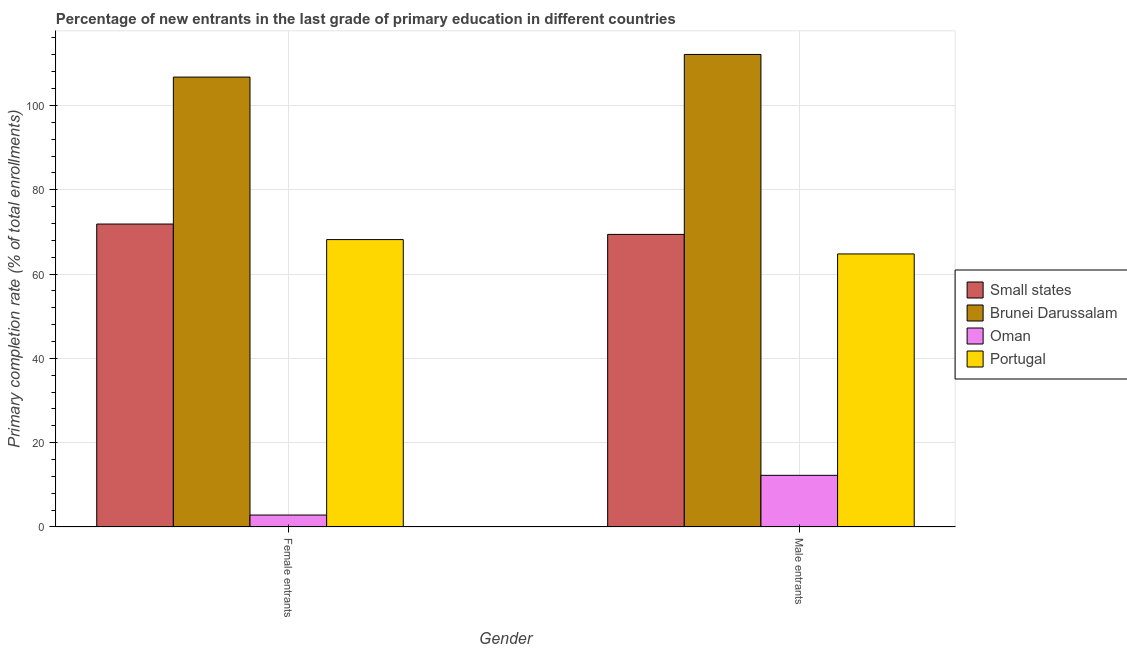How many different coloured bars are there?
Your response must be concise. 4. How many groups of bars are there?
Your answer should be very brief. 2. Are the number of bars per tick equal to the number of legend labels?
Your answer should be compact. Yes. Are the number of bars on each tick of the X-axis equal?
Give a very brief answer. Yes. What is the label of the 2nd group of bars from the left?
Provide a succinct answer. Male entrants. What is the primary completion rate of male entrants in Oman?
Ensure brevity in your answer.  12.26. Across all countries, what is the maximum primary completion rate of female entrants?
Give a very brief answer. 106.72. Across all countries, what is the minimum primary completion rate of male entrants?
Provide a short and direct response. 12.26. In which country was the primary completion rate of female entrants maximum?
Make the answer very short. Brunei Darussalam. In which country was the primary completion rate of male entrants minimum?
Your response must be concise. Oman. What is the total primary completion rate of female entrants in the graph?
Keep it short and to the point. 249.6. What is the difference between the primary completion rate of female entrants in Brunei Darussalam and that in Oman?
Provide a succinct answer. 103.89. What is the difference between the primary completion rate of male entrants in Small states and the primary completion rate of female entrants in Portugal?
Make the answer very short. 1.23. What is the average primary completion rate of female entrants per country?
Your response must be concise. 62.4. What is the difference between the primary completion rate of male entrants and primary completion rate of female entrants in Portugal?
Provide a short and direct response. -3.4. What is the ratio of the primary completion rate of female entrants in Oman to that in Brunei Darussalam?
Provide a succinct answer. 0.03. Is the primary completion rate of male entrants in Oman less than that in Brunei Darussalam?
Your answer should be very brief. Yes. In how many countries, is the primary completion rate of female entrants greater than the average primary completion rate of female entrants taken over all countries?
Provide a succinct answer. 3. What does the 4th bar from the left in Male entrants represents?
Offer a terse response. Portugal. What does the 4th bar from the right in Male entrants represents?
Provide a short and direct response. Small states. Does the graph contain any zero values?
Provide a succinct answer. No. Does the graph contain grids?
Your response must be concise. Yes. What is the title of the graph?
Make the answer very short. Percentage of new entrants in the last grade of primary education in different countries. Does "Belarus" appear as one of the legend labels in the graph?
Offer a very short reply. No. What is the label or title of the Y-axis?
Ensure brevity in your answer.  Primary completion rate (% of total enrollments). What is the Primary completion rate (% of total enrollments) of Small states in Female entrants?
Make the answer very short. 71.86. What is the Primary completion rate (% of total enrollments) in Brunei Darussalam in Female entrants?
Offer a terse response. 106.72. What is the Primary completion rate (% of total enrollments) in Oman in Female entrants?
Your response must be concise. 2.83. What is the Primary completion rate (% of total enrollments) in Portugal in Female entrants?
Give a very brief answer. 68.18. What is the Primary completion rate (% of total enrollments) in Small states in Male entrants?
Your answer should be compact. 69.41. What is the Primary completion rate (% of total enrollments) in Brunei Darussalam in Male entrants?
Ensure brevity in your answer.  112.09. What is the Primary completion rate (% of total enrollments) of Oman in Male entrants?
Offer a very short reply. 12.26. What is the Primary completion rate (% of total enrollments) in Portugal in Male entrants?
Keep it short and to the point. 64.77. Across all Gender, what is the maximum Primary completion rate (% of total enrollments) in Small states?
Your answer should be compact. 71.86. Across all Gender, what is the maximum Primary completion rate (% of total enrollments) in Brunei Darussalam?
Provide a short and direct response. 112.09. Across all Gender, what is the maximum Primary completion rate (% of total enrollments) in Oman?
Offer a very short reply. 12.26. Across all Gender, what is the maximum Primary completion rate (% of total enrollments) in Portugal?
Your answer should be very brief. 68.18. Across all Gender, what is the minimum Primary completion rate (% of total enrollments) of Small states?
Offer a very short reply. 69.41. Across all Gender, what is the minimum Primary completion rate (% of total enrollments) in Brunei Darussalam?
Offer a very short reply. 106.72. Across all Gender, what is the minimum Primary completion rate (% of total enrollments) in Oman?
Ensure brevity in your answer.  2.83. Across all Gender, what is the minimum Primary completion rate (% of total enrollments) of Portugal?
Provide a succinct answer. 64.77. What is the total Primary completion rate (% of total enrollments) in Small states in the graph?
Provide a short and direct response. 141.27. What is the total Primary completion rate (% of total enrollments) in Brunei Darussalam in the graph?
Your answer should be compact. 218.81. What is the total Primary completion rate (% of total enrollments) of Oman in the graph?
Make the answer very short. 15.09. What is the total Primary completion rate (% of total enrollments) of Portugal in the graph?
Ensure brevity in your answer.  132.95. What is the difference between the Primary completion rate (% of total enrollments) of Small states in Female entrants and that in Male entrants?
Your response must be concise. 2.46. What is the difference between the Primary completion rate (% of total enrollments) of Brunei Darussalam in Female entrants and that in Male entrants?
Provide a succinct answer. -5.37. What is the difference between the Primary completion rate (% of total enrollments) of Oman in Female entrants and that in Male entrants?
Your answer should be very brief. -9.42. What is the difference between the Primary completion rate (% of total enrollments) in Portugal in Female entrants and that in Male entrants?
Offer a terse response. 3.4. What is the difference between the Primary completion rate (% of total enrollments) in Small states in Female entrants and the Primary completion rate (% of total enrollments) in Brunei Darussalam in Male entrants?
Give a very brief answer. -40.23. What is the difference between the Primary completion rate (% of total enrollments) of Small states in Female entrants and the Primary completion rate (% of total enrollments) of Oman in Male entrants?
Provide a succinct answer. 59.61. What is the difference between the Primary completion rate (% of total enrollments) in Small states in Female entrants and the Primary completion rate (% of total enrollments) in Portugal in Male entrants?
Your answer should be very brief. 7.09. What is the difference between the Primary completion rate (% of total enrollments) in Brunei Darussalam in Female entrants and the Primary completion rate (% of total enrollments) in Oman in Male entrants?
Your response must be concise. 94.47. What is the difference between the Primary completion rate (% of total enrollments) of Brunei Darussalam in Female entrants and the Primary completion rate (% of total enrollments) of Portugal in Male entrants?
Your answer should be very brief. 41.95. What is the difference between the Primary completion rate (% of total enrollments) of Oman in Female entrants and the Primary completion rate (% of total enrollments) of Portugal in Male entrants?
Ensure brevity in your answer.  -61.94. What is the average Primary completion rate (% of total enrollments) in Small states per Gender?
Your answer should be very brief. 70.64. What is the average Primary completion rate (% of total enrollments) of Brunei Darussalam per Gender?
Offer a very short reply. 109.41. What is the average Primary completion rate (% of total enrollments) in Oman per Gender?
Offer a terse response. 7.55. What is the average Primary completion rate (% of total enrollments) of Portugal per Gender?
Offer a very short reply. 66.47. What is the difference between the Primary completion rate (% of total enrollments) of Small states and Primary completion rate (% of total enrollments) of Brunei Darussalam in Female entrants?
Keep it short and to the point. -34.86. What is the difference between the Primary completion rate (% of total enrollments) in Small states and Primary completion rate (% of total enrollments) in Oman in Female entrants?
Provide a short and direct response. 69.03. What is the difference between the Primary completion rate (% of total enrollments) of Small states and Primary completion rate (% of total enrollments) of Portugal in Female entrants?
Make the answer very short. 3.69. What is the difference between the Primary completion rate (% of total enrollments) of Brunei Darussalam and Primary completion rate (% of total enrollments) of Oman in Female entrants?
Keep it short and to the point. 103.89. What is the difference between the Primary completion rate (% of total enrollments) of Brunei Darussalam and Primary completion rate (% of total enrollments) of Portugal in Female entrants?
Offer a terse response. 38.55. What is the difference between the Primary completion rate (% of total enrollments) in Oman and Primary completion rate (% of total enrollments) in Portugal in Female entrants?
Your response must be concise. -65.34. What is the difference between the Primary completion rate (% of total enrollments) of Small states and Primary completion rate (% of total enrollments) of Brunei Darussalam in Male entrants?
Offer a terse response. -42.68. What is the difference between the Primary completion rate (% of total enrollments) in Small states and Primary completion rate (% of total enrollments) in Oman in Male entrants?
Ensure brevity in your answer.  57.15. What is the difference between the Primary completion rate (% of total enrollments) in Small states and Primary completion rate (% of total enrollments) in Portugal in Male entrants?
Make the answer very short. 4.64. What is the difference between the Primary completion rate (% of total enrollments) in Brunei Darussalam and Primary completion rate (% of total enrollments) in Oman in Male entrants?
Your answer should be very brief. 99.84. What is the difference between the Primary completion rate (% of total enrollments) of Brunei Darussalam and Primary completion rate (% of total enrollments) of Portugal in Male entrants?
Keep it short and to the point. 47.32. What is the difference between the Primary completion rate (% of total enrollments) of Oman and Primary completion rate (% of total enrollments) of Portugal in Male entrants?
Provide a succinct answer. -52.51. What is the ratio of the Primary completion rate (% of total enrollments) in Small states in Female entrants to that in Male entrants?
Provide a short and direct response. 1.04. What is the ratio of the Primary completion rate (% of total enrollments) in Brunei Darussalam in Female entrants to that in Male entrants?
Make the answer very short. 0.95. What is the ratio of the Primary completion rate (% of total enrollments) of Oman in Female entrants to that in Male entrants?
Offer a terse response. 0.23. What is the ratio of the Primary completion rate (% of total enrollments) in Portugal in Female entrants to that in Male entrants?
Your response must be concise. 1.05. What is the difference between the highest and the second highest Primary completion rate (% of total enrollments) in Small states?
Keep it short and to the point. 2.46. What is the difference between the highest and the second highest Primary completion rate (% of total enrollments) of Brunei Darussalam?
Offer a very short reply. 5.37. What is the difference between the highest and the second highest Primary completion rate (% of total enrollments) of Oman?
Ensure brevity in your answer.  9.42. What is the difference between the highest and the second highest Primary completion rate (% of total enrollments) of Portugal?
Give a very brief answer. 3.4. What is the difference between the highest and the lowest Primary completion rate (% of total enrollments) in Small states?
Your response must be concise. 2.46. What is the difference between the highest and the lowest Primary completion rate (% of total enrollments) of Brunei Darussalam?
Your response must be concise. 5.37. What is the difference between the highest and the lowest Primary completion rate (% of total enrollments) in Oman?
Make the answer very short. 9.42. What is the difference between the highest and the lowest Primary completion rate (% of total enrollments) in Portugal?
Your response must be concise. 3.4. 